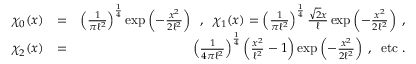Convert formula to latex. <formula><loc_0><loc_0><loc_500><loc_500>\begin{array} { r l r } { \chi _ { 0 } ( x ) } & { = } & { \left ( \frac { 1 } { \pi \ell ^ { 2 } } \right ) ^ { \frac { 1 } { 4 } } \exp \left ( - \frac { x ^ { 2 } } { 2 \ell ^ { 2 } } \right ) \, , \, \chi _ { 1 } ( x ) = \left ( \frac { 1 } { \pi \ell ^ { 2 } } \right ) ^ { \frac { 1 } { 4 } } \frac { \sqrt { 2 } x } { \ell } \exp \left ( - \frac { x ^ { 2 } } { 2 \ell ^ { 2 } } \right ) \, , } \\ { \chi _ { 2 } ( x ) } & { = } & { \left ( \frac { 1 } { 4 \pi \ell ^ { 2 } } \right ) ^ { \frac { 1 } { 4 } } \left ( \frac { x ^ { 2 } } { \ell ^ { 2 } } - 1 \right ) \exp \left ( - \frac { x ^ { 2 } } { 2 \ell ^ { 2 } } \right ) \, , \, e t c \, . } \end{array}</formula> 